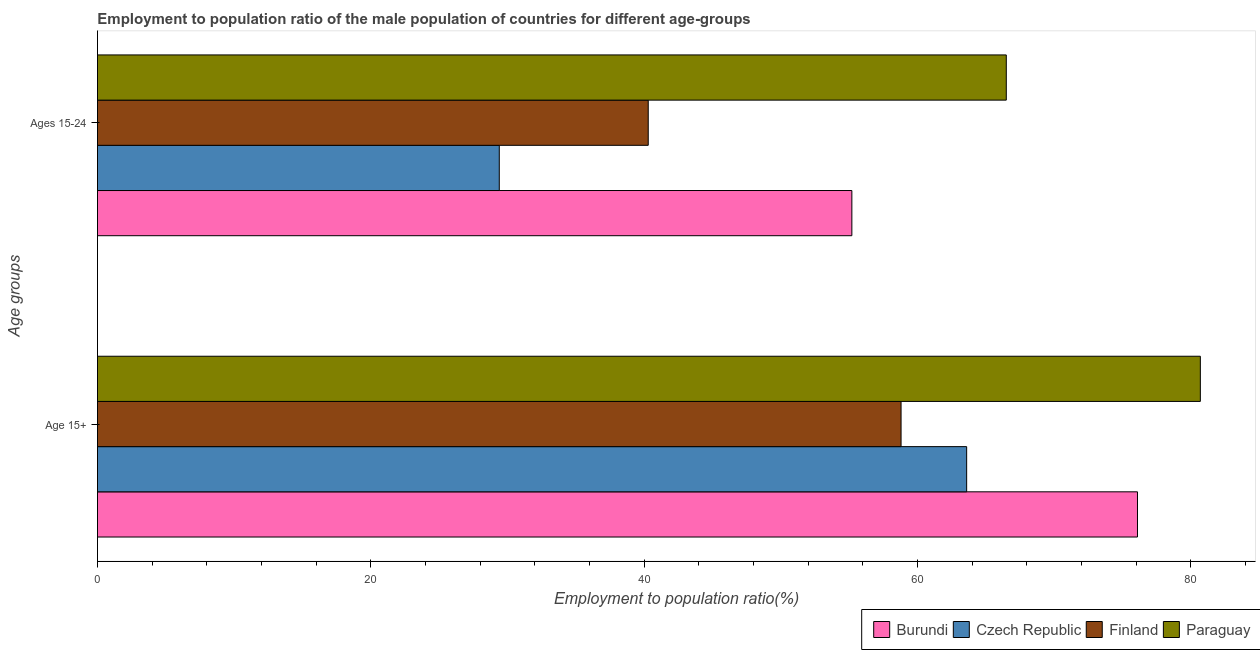How many groups of bars are there?
Give a very brief answer. 2. How many bars are there on the 1st tick from the top?
Give a very brief answer. 4. What is the label of the 1st group of bars from the top?
Keep it short and to the point. Ages 15-24. What is the employment to population ratio(age 15-24) in Burundi?
Provide a succinct answer. 55.2. Across all countries, what is the maximum employment to population ratio(age 15-24)?
Provide a short and direct response. 66.5. Across all countries, what is the minimum employment to population ratio(age 15-24)?
Provide a succinct answer. 29.4. In which country was the employment to population ratio(age 15+) maximum?
Give a very brief answer. Paraguay. In which country was the employment to population ratio(age 15-24) minimum?
Make the answer very short. Czech Republic. What is the total employment to population ratio(age 15+) in the graph?
Provide a short and direct response. 279.2. What is the difference between the employment to population ratio(age 15-24) in Finland and that in Paraguay?
Provide a short and direct response. -26.2. What is the difference between the employment to population ratio(age 15-24) in Finland and the employment to population ratio(age 15+) in Paraguay?
Provide a succinct answer. -40.4. What is the average employment to population ratio(age 15+) per country?
Offer a very short reply. 69.8. What is the difference between the employment to population ratio(age 15-24) and employment to population ratio(age 15+) in Burundi?
Offer a terse response. -20.9. In how many countries, is the employment to population ratio(age 15-24) greater than 16 %?
Provide a succinct answer. 4. What is the ratio of the employment to population ratio(age 15+) in Czech Republic to that in Burundi?
Ensure brevity in your answer.  0.84. Is the employment to population ratio(age 15+) in Burundi less than that in Czech Republic?
Offer a terse response. No. In how many countries, is the employment to population ratio(age 15+) greater than the average employment to population ratio(age 15+) taken over all countries?
Your answer should be very brief. 2. What does the 3rd bar from the top in Age 15+ represents?
Provide a succinct answer. Czech Republic. What does the 4th bar from the bottom in Age 15+ represents?
Your response must be concise. Paraguay. How many countries are there in the graph?
Give a very brief answer. 4. What is the difference between two consecutive major ticks on the X-axis?
Make the answer very short. 20. Are the values on the major ticks of X-axis written in scientific E-notation?
Provide a short and direct response. No. Does the graph contain any zero values?
Your response must be concise. No. Does the graph contain grids?
Make the answer very short. No. How many legend labels are there?
Give a very brief answer. 4. How are the legend labels stacked?
Provide a succinct answer. Horizontal. What is the title of the graph?
Offer a terse response. Employment to population ratio of the male population of countries for different age-groups. What is the label or title of the X-axis?
Make the answer very short. Employment to population ratio(%). What is the label or title of the Y-axis?
Offer a very short reply. Age groups. What is the Employment to population ratio(%) of Burundi in Age 15+?
Offer a very short reply. 76.1. What is the Employment to population ratio(%) of Czech Republic in Age 15+?
Offer a terse response. 63.6. What is the Employment to population ratio(%) in Finland in Age 15+?
Your response must be concise. 58.8. What is the Employment to population ratio(%) in Paraguay in Age 15+?
Keep it short and to the point. 80.7. What is the Employment to population ratio(%) in Burundi in Ages 15-24?
Your answer should be very brief. 55.2. What is the Employment to population ratio(%) in Czech Republic in Ages 15-24?
Make the answer very short. 29.4. What is the Employment to population ratio(%) of Finland in Ages 15-24?
Keep it short and to the point. 40.3. What is the Employment to population ratio(%) in Paraguay in Ages 15-24?
Provide a succinct answer. 66.5. Across all Age groups, what is the maximum Employment to population ratio(%) of Burundi?
Provide a short and direct response. 76.1. Across all Age groups, what is the maximum Employment to population ratio(%) of Czech Republic?
Provide a short and direct response. 63.6. Across all Age groups, what is the maximum Employment to population ratio(%) of Finland?
Your answer should be compact. 58.8. Across all Age groups, what is the maximum Employment to population ratio(%) of Paraguay?
Give a very brief answer. 80.7. Across all Age groups, what is the minimum Employment to population ratio(%) in Burundi?
Your answer should be very brief. 55.2. Across all Age groups, what is the minimum Employment to population ratio(%) in Czech Republic?
Your response must be concise. 29.4. Across all Age groups, what is the minimum Employment to population ratio(%) of Finland?
Your answer should be compact. 40.3. Across all Age groups, what is the minimum Employment to population ratio(%) in Paraguay?
Provide a short and direct response. 66.5. What is the total Employment to population ratio(%) of Burundi in the graph?
Keep it short and to the point. 131.3. What is the total Employment to population ratio(%) of Czech Republic in the graph?
Provide a short and direct response. 93. What is the total Employment to population ratio(%) of Finland in the graph?
Keep it short and to the point. 99.1. What is the total Employment to population ratio(%) in Paraguay in the graph?
Offer a terse response. 147.2. What is the difference between the Employment to population ratio(%) in Burundi in Age 15+ and that in Ages 15-24?
Ensure brevity in your answer.  20.9. What is the difference between the Employment to population ratio(%) of Czech Republic in Age 15+ and that in Ages 15-24?
Offer a very short reply. 34.2. What is the difference between the Employment to population ratio(%) of Paraguay in Age 15+ and that in Ages 15-24?
Provide a short and direct response. 14.2. What is the difference between the Employment to population ratio(%) in Burundi in Age 15+ and the Employment to population ratio(%) in Czech Republic in Ages 15-24?
Keep it short and to the point. 46.7. What is the difference between the Employment to population ratio(%) in Burundi in Age 15+ and the Employment to population ratio(%) in Finland in Ages 15-24?
Provide a succinct answer. 35.8. What is the difference between the Employment to population ratio(%) of Burundi in Age 15+ and the Employment to population ratio(%) of Paraguay in Ages 15-24?
Offer a terse response. 9.6. What is the difference between the Employment to population ratio(%) of Czech Republic in Age 15+ and the Employment to population ratio(%) of Finland in Ages 15-24?
Provide a succinct answer. 23.3. What is the difference between the Employment to population ratio(%) in Czech Republic in Age 15+ and the Employment to population ratio(%) in Paraguay in Ages 15-24?
Ensure brevity in your answer.  -2.9. What is the average Employment to population ratio(%) in Burundi per Age groups?
Provide a succinct answer. 65.65. What is the average Employment to population ratio(%) of Czech Republic per Age groups?
Your response must be concise. 46.5. What is the average Employment to population ratio(%) of Finland per Age groups?
Your answer should be compact. 49.55. What is the average Employment to population ratio(%) in Paraguay per Age groups?
Your answer should be very brief. 73.6. What is the difference between the Employment to population ratio(%) in Burundi and Employment to population ratio(%) in Finland in Age 15+?
Provide a short and direct response. 17.3. What is the difference between the Employment to population ratio(%) in Czech Republic and Employment to population ratio(%) in Paraguay in Age 15+?
Ensure brevity in your answer.  -17.1. What is the difference between the Employment to population ratio(%) of Finland and Employment to population ratio(%) of Paraguay in Age 15+?
Ensure brevity in your answer.  -21.9. What is the difference between the Employment to population ratio(%) of Burundi and Employment to population ratio(%) of Czech Republic in Ages 15-24?
Provide a succinct answer. 25.8. What is the difference between the Employment to population ratio(%) of Czech Republic and Employment to population ratio(%) of Paraguay in Ages 15-24?
Give a very brief answer. -37.1. What is the difference between the Employment to population ratio(%) of Finland and Employment to population ratio(%) of Paraguay in Ages 15-24?
Make the answer very short. -26.2. What is the ratio of the Employment to population ratio(%) in Burundi in Age 15+ to that in Ages 15-24?
Give a very brief answer. 1.38. What is the ratio of the Employment to population ratio(%) in Czech Republic in Age 15+ to that in Ages 15-24?
Make the answer very short. 2.16. What is the ratio of the Employment to population ratio(%) in Finland in Age 15+ to that in Ages 15-24?
Your answer should be very brief. 1.46. What is the ratio of the Employment to population ratio(%) of Paraguay in Age 15+ to that in Ages 15-24?
Offer a terse response. 1.21. What is the difference between the highest and the second highest Employment to population ratio(%) in Burundi?
Give a very brief answer. 20.9. What is the difference between the highest and the second highest Employment to population ratio(%) in Czech Republic?
Ensure brevity in your answer.  34.2. What is the difference between the highest and the second highest Employment to population ratio(%) in Finland?
Make the answer very short. 18.5. What is the difference between the highest and the second highest Employment to population ratio(%) of Paraguay?
Give a very brief answer. 14.2. What is the difference between the highest and the lowest Employment to population ratio(%) in Burundi?
Provide a succinct answer. 20.9. What is the difference between the highest and the lowest Employment to population ratio(%) of Czech Republic?
Your answer should be very brief. 34.2. What is the difference between the highest and the lowest Employment to population ratio(%) of Finland?
Ensure brevity in your answer.  18.5. What is the difference between the highest and the lowest Employment to population ratio(%) of Paraguay?
Keep it short and to the point. 14.2. 